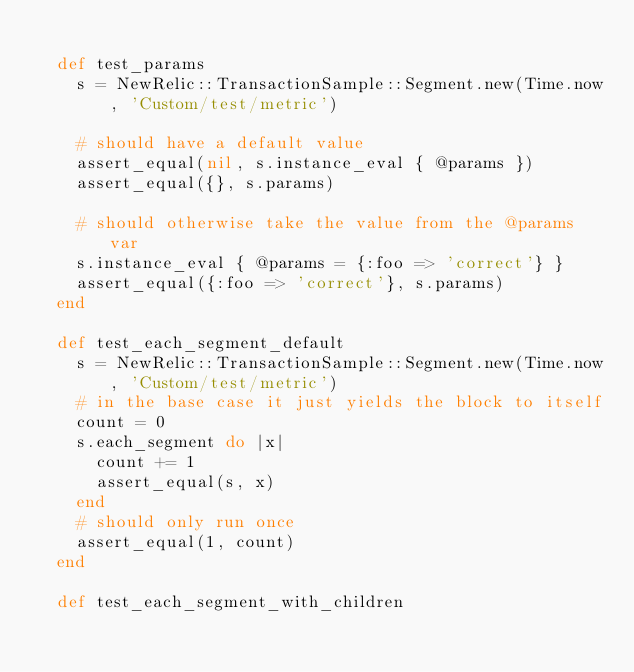<code> <loc_0><loc_0><loc_500><loc_500><_Ruby_>
  def test_params
    s = NewRelic::TransactionSample::Segment.new(Time.now, 'Custom/test/metric')

    # should have a default value
    assert_equal(nil, s.instance_eval { @params })
    assert_equal({}, s.params)

    # should otherwise take the value from the @params var
    s.instance_eval { @params = {:foo => 'correct'} }
    assert_equal({:foo => 'correct'}, s.params)
  end

  def test_each_segment_default
    s = NewRelic::TransactionSample::Segment.new(Time.now, 'Custom/test/metric')
    # in the base case it just yields the block to itself
    count = 0
    s.each_segment do |x|
      count += 1
      assert_equal(s, x)
    end
    # should only run once
    assert_equal(1, count)
  end

  def test_each_segment_with_children</code> 